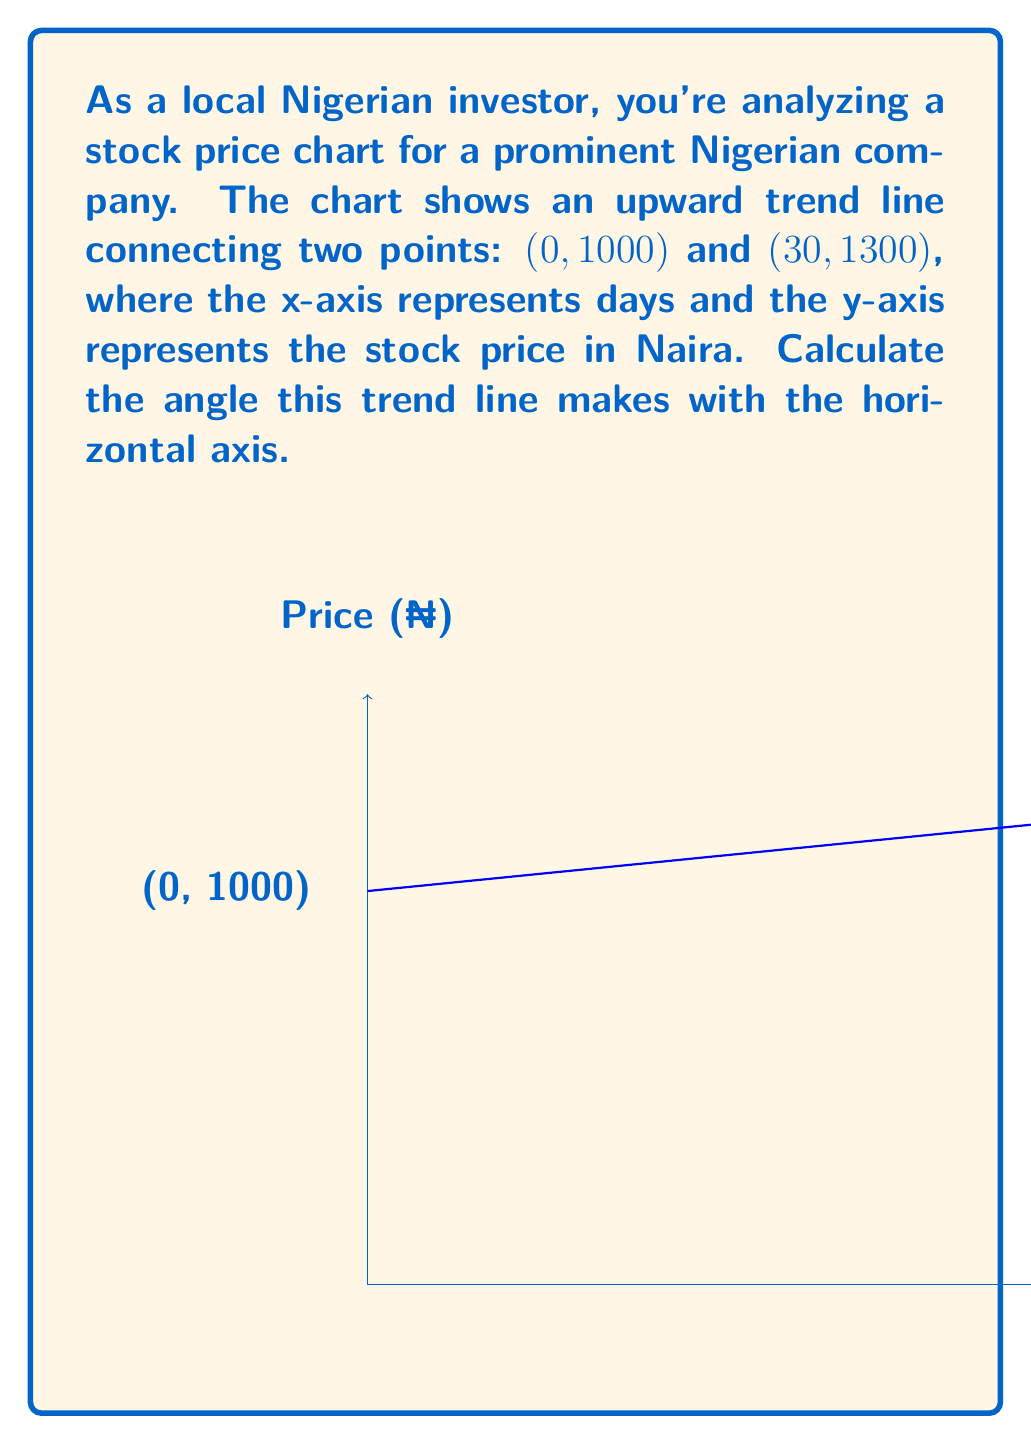Can you answer this question? To calculate the angle of the trend line, we'll use the arctangent function. Here's the step-by-step process:

1) First, we need to calculate the slope of the line. The slope formula is:

   $m = \frac{y_2 - y_1}{x_2 - x_1}$

2) Plugging in our values:
   $m = \frac{1300 - 1000}{30 - 0} = \frac{300}{30} = 10$

3) The slope represents the change in y for every 1 unit change in x. In this case, the price increases by 10 Naira per day.

4) To find the angle, we use the arctangent of the slope:

   $\theta = \arctan(m)$

5) Substituting our slope:
   $\theta = \arctan(10)$

6) Using a calculator or trigonometric tables:
   $\theta \approx 84.29°$

Therefore, the angle the trend line makes with the horizontal axis is approximately 84.29 degrees.
Answer: $84.29°$ 